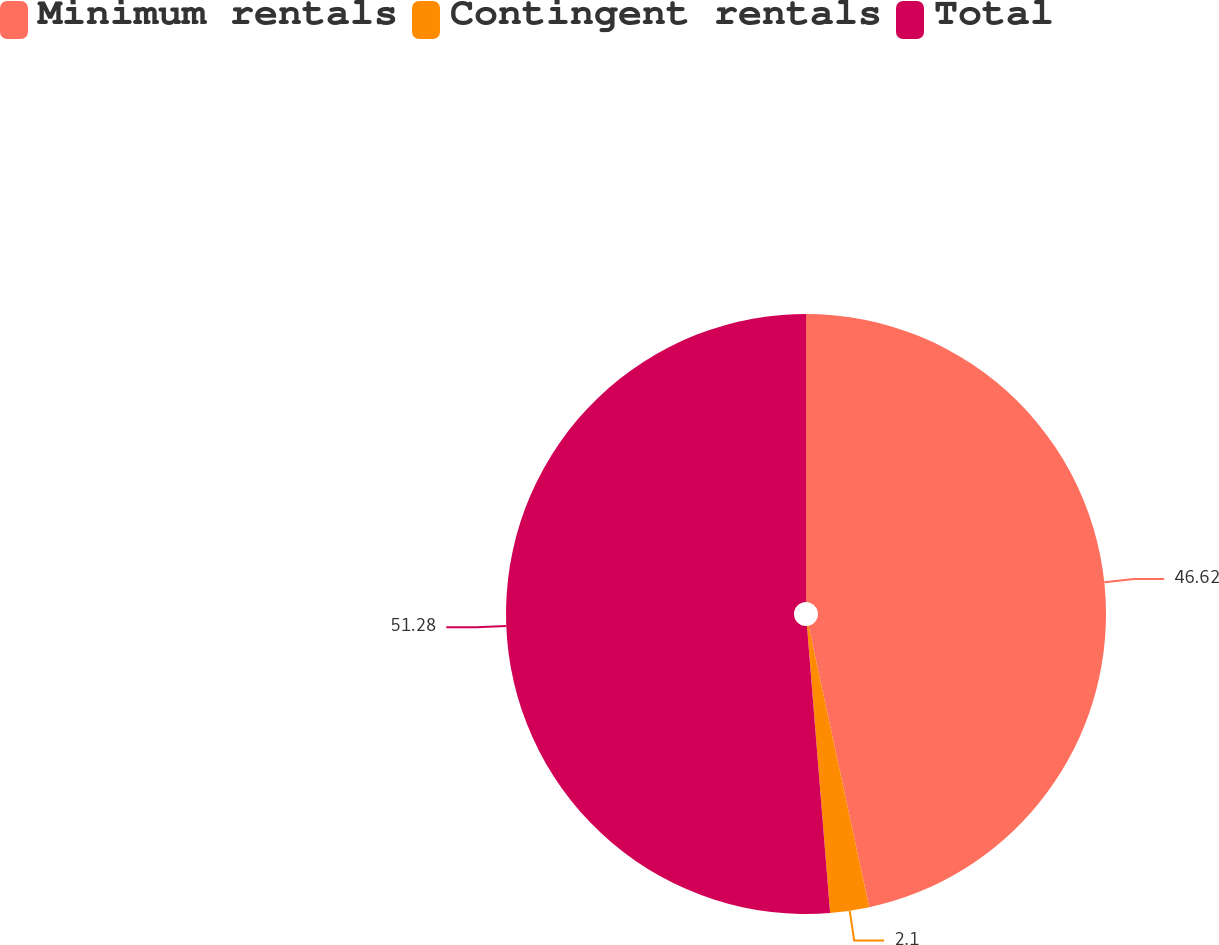<chart> <loc_0><loc_0><loc_500><loc_500><pie_chart><fcel>Minimum rentals<fcel>Contingent rentals<fcel>Total<nl><fcel>46.62%<fcel>2.1%<fcel>51.28%<nl></chart> 